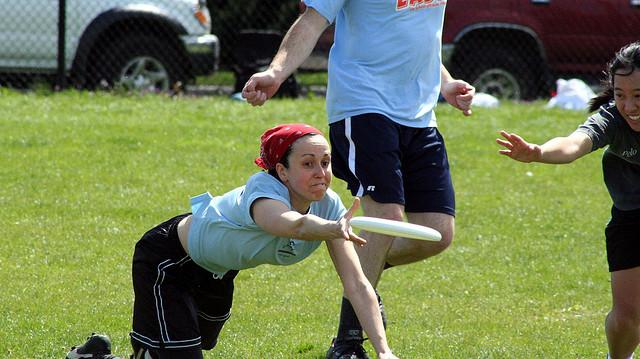What is the woman ready to do? Please explain your reasoning. catch. Her hands are outstretched towards the frisbee which is seen going in the direction of her hands.  collision is imminent. 